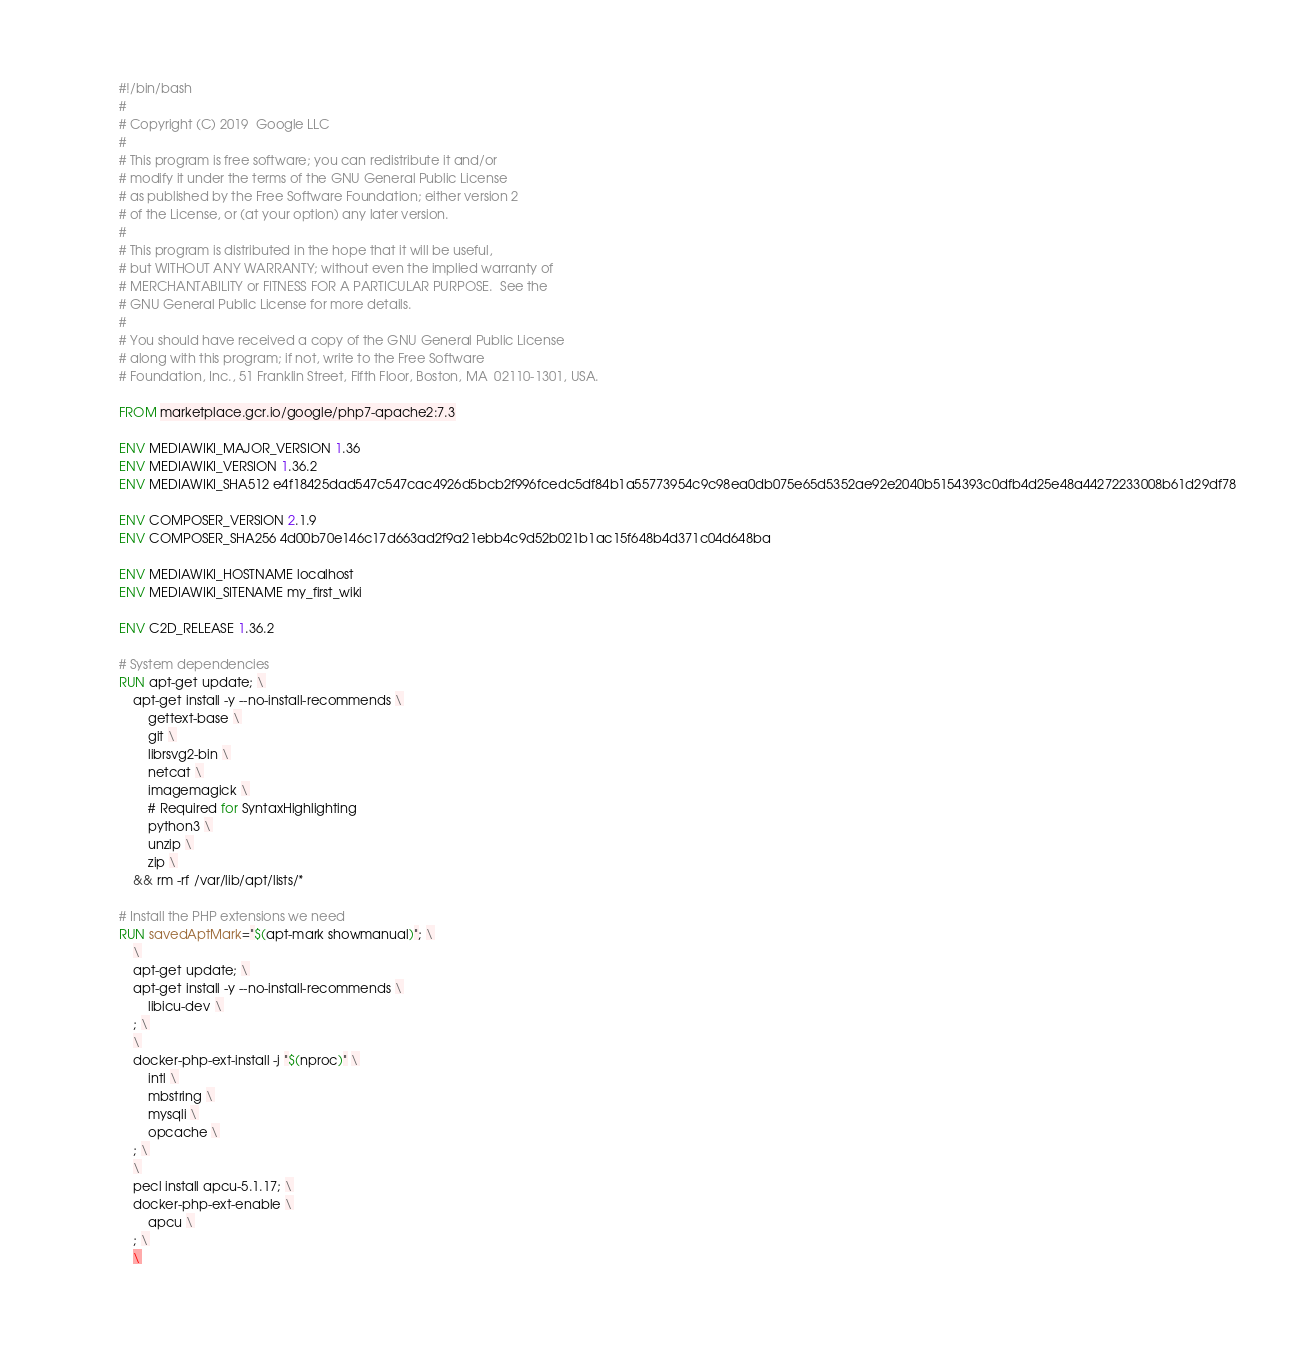Convert code to text. <code><loc_0><loc_0><loc_500><loc_500><_Dockerfile_>#!/bin/bash
#
# Copyright (C) 2019  Google LLC
#
# This program is free software; you can redistribute it and/or
# modify it under the terms of the GNU General Public License
# as published by the Free Software Foundation; either version 2
# of the License, or (at your option) any later version.
#
# This program is distributed in the hope that it will be useful,
# but WITHOUT ANY WARRANTY; without even the implied warranty of
# MERCHANTABILITY or FITNESS FOR A PARTICULAR PURPOSE.  See the
# GNU General Public License for more details.
#
# You should have received a copy of the GNU General Public License
# along with this program; if not, write to the Free Software
# Foundation, Inc., 51 Franklin Street, Fifth Floor, Boston, MA  02110-1301, USA.

FROM marketplace.gcr.io/google/php7-apache2:7.3

ENV MEDIAWIKI_MAJOR_VERSION 1.36
ENV MEDIAWIKI_VERSION 1.36.2
ENV MEDIAWIKI_SHA512 e4f18425dad547c547cac4926d5bcb2f996fcedc5df84b1a55773954c9c98ea0db075e65d5352ae92e2040b5154393c0dfb4d25e48a44272233008b61d29df78

ENV COMPOSER_VERSION 2.1.9
ENV COMPOSER_SHA256 4d00b70e146c17d663ad2f9a21ebb4c9d52b021b1ac15f648b4d371c04d648ba

ENV MEDIAWIKI_HOSTNAME localhost
ENV MEDIAWIKI_SITENAME my_first_wiki

ENV C2D_RELEASE 1.36.2

# System dependencies
RUN apt-get update; \
    apt-get install -y --no-install-recommends \
        gettext-base \
        git \
        librsvg2-bin \
        netcat \
        imagemagick \
        # Required for SyntaxHighlighting
        python3 \
        unzip \
        zip \
    && rm -rf /var/lib/apt/lists/*

# Install the PHP extensions we need
RUN savedAptMark="$(apt-mark showmanual)"; \
    \
    apt-get update; \
    apt-get install -y --no-install-recommends \
        libicu-dev \
    ; \
    \
    docker-php-ext-install -j "$(nproc)" \
        intl \
        mbstring \
        mysqli \
        opcache \
    ; \
    \
    pecl install apcu-5.1.17; \
    docker-php-ext-enable \
        apcu \
    ; \
    \</code> 